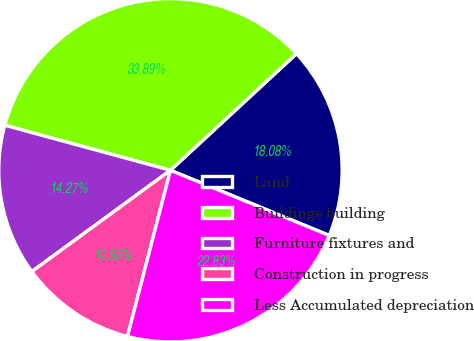Convert chart. <chart><loc_0><loc_0><loc_500><loc_500><pie_chart><fcel>Land<fcel>Buildings building<fcel>Furniture fixtures and<fcel>Construction in progress<fcel>Less Accumulated depreciation<nl><fcel>18.08%<fcel>33.89%<fcel>14.27%<fcel>10.93%<fcel>22.83%<nl></chart> 